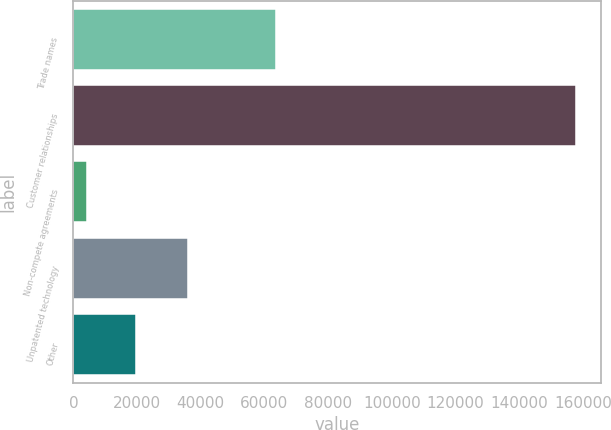<chart> <loc_0><loc_0><loc_500><loc_500><bar_chart><fcel>Trade names<fcel>Customer relationships<fcel>Non-compete agreements<fcel>Unpatented technology<fcel>Other<nl><fcel>63589<fcel>157890<fcel>4268<fcel>36047<fcel>19630.2<nl></chart> 